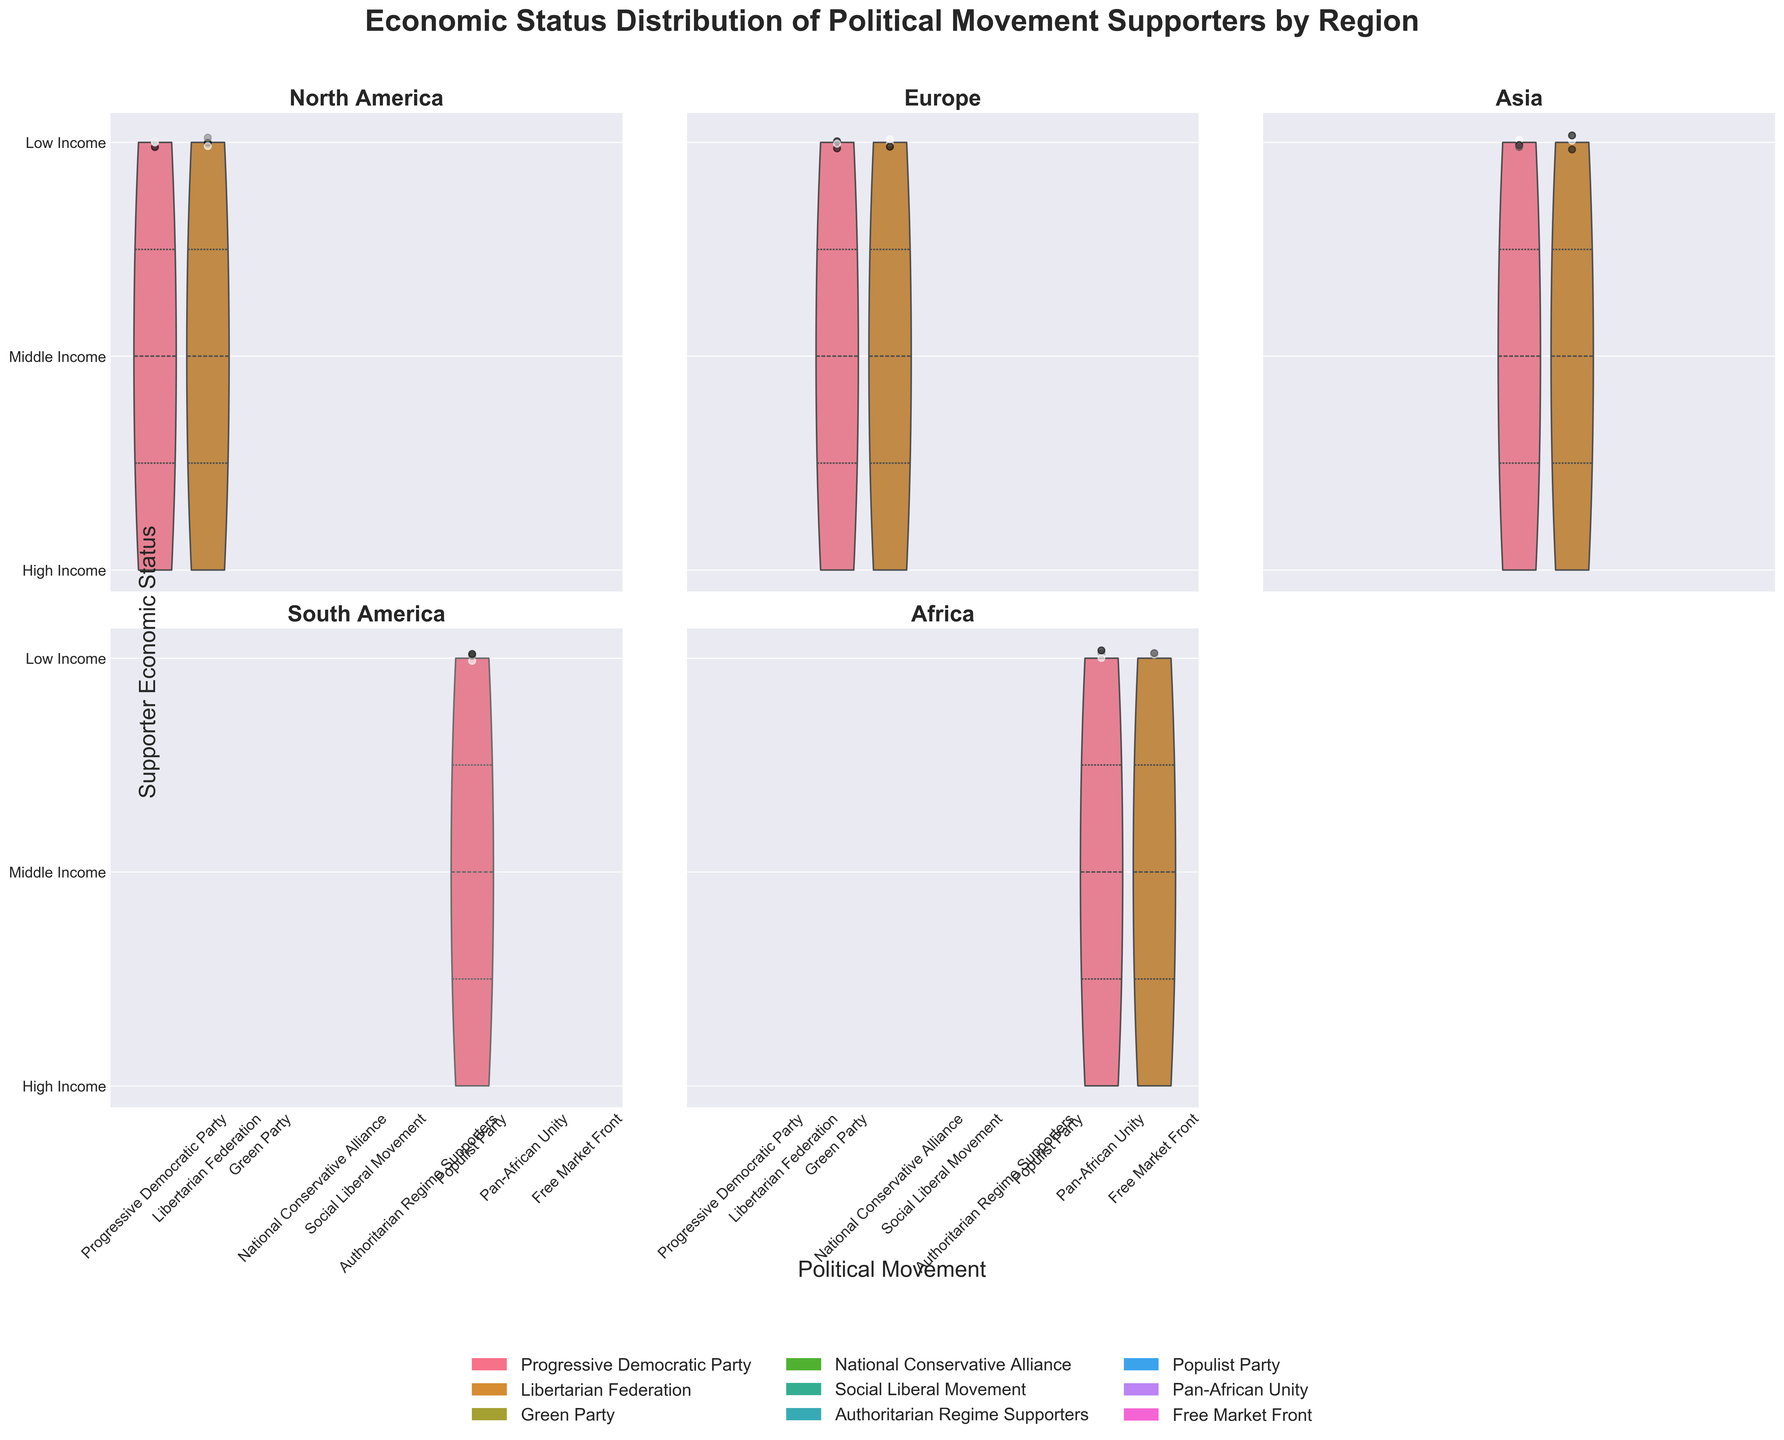How many political movements are represented in the plot? The legend at the bottom of the plot indicates each political movement by color. By counting these, we can see there are six different political movements displayed.
Answer: Six What does the plot's title describe? The title at the top of the figure reads, "Economic Status Distribution of Political Movement Supporters by Region," summarizing the content of the subplots, indicating the distribution of supporters' economic status across regions and political movements.
Answer: Economic status distribution of political movement supporters by region Which political movement has the widest distribution of economic statuses in North America? By looking at the width of the violins in the North America subplot, we can observe that the "Libertarian Federation" has a wider distribution across economic statuses compared to the "Progressive Democratic Party."
Answer: Libertarian Federation Compare the economic status distribution of supporters of the Green Party in Europe with the Populist Party in South America. In Europe, the Green Party's supporters show a fairly even spread across low, middle, and high incomes, whereas in South America, Populist Party supporters demonstrate a more diverse spread which appears more concentrated at the lower income levels.
Answer: Green Party's spread is even; Populist Party's spread is more diverse Which region shows the most diverse set of political movements based on the number of movements represented in its subplot? By counting the number of distinct violins (political movements) in each subplot, it is evident that both North America and Africa have two movements each, Europe and Asia have two, while South America has only one. Hence, all regions, except South America, show a diversity of political movements.
Answer: North America, Europe, Africa, and Asia Which political movement in Asia has a more concentrated distribution of supporter economic statuses? Examining the width and compactness of the violins in the Asia subplot shows that "Social Liberal Movement" has a more concentrated distribution compared to "Authoritarian Regime Supporters."
Answer: Social Liberal Movement Do any regions have a political movement with exclusively high-income supporters? None of the subplots show a violin corresponding to a political movement that is entirely restricted to the high-income bracket. All movements span across multiple economic statuses.
Answer: No What region has the narrowest distribution of any political movement, and which movement is it? By observing the width of the violins in all the subplots, the Populist Party in South America has an extremely narrow distribution indicating very little economic diversity among its supporters.
Answer: South America, Populist Party Which axes represent the economic status and how are they labeled across the subplots? The vertical axes across all subplots represent the "Supporter Economic Status," which is labeled on the left side of the overall figure.
Answer: Vertical axes, "Supporter Economic Status" How is the color representing different political movements across the plots achieved? The use of different colors for each political movement is indicated in the legend at the bottom of the figure, which associates a specific color with each movement. These colors help to visually differentiate the movements in the plots.
Answer: Colors differentiate political movements 